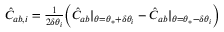<formula> <loc_0><loc_0><loc_500><loc_500>\begin{array} { r } { \hat { C } _ { a b , i } = \frac { 1 } { 2 \delta \theta _ { i } } \left ( \hat { C } _ { a b } | _ { \theta = \theta _ { * } + \delta \theta _ { i } } - \hat { C } _ { a b } | _ { \theta = \theta _ { * } - \delta \theta _ { i } } \right ) } \end{array}</formula> 